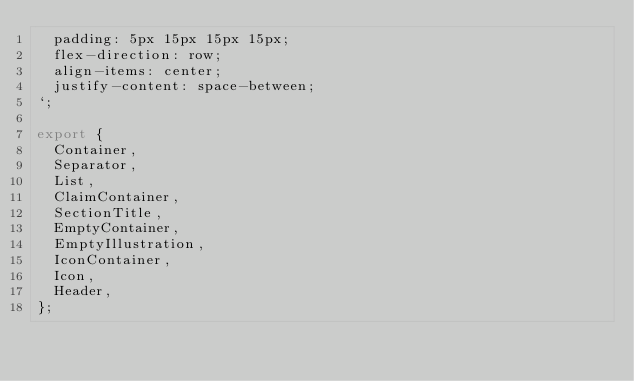Convert code to text. <code><loc_0><loc_0><loc_500><loc_500><_JavaScript_>  padding: 5px 15px 15px 15px;
  flex-direction: row;
  align-items: center;
  justify-content: space-between;
`;

export {
  Container,
  Separator,
  List,
  ClaimContainer,
  SectionTitle,
  EmptyContainer,
  EmptyIllustration,
  IconContainer,
  Icon,
  Header,
};
</code> 